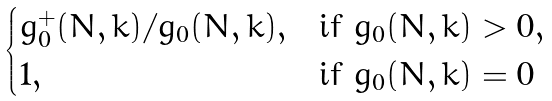Convert formula to latex. <formula><loc_0><loc_0><loc_500><loc_500>\begin{cases} g _ { 0 } ^ { + } ( N , k ) / g _ { 0 } ( N , k ) , & \text {if } g _ { 0 } ( N , k ) > 0 , \\ 1 , & \text {if } g _ { 0 } ( N , k ) = 0 \\ \end{cases}</formula> 